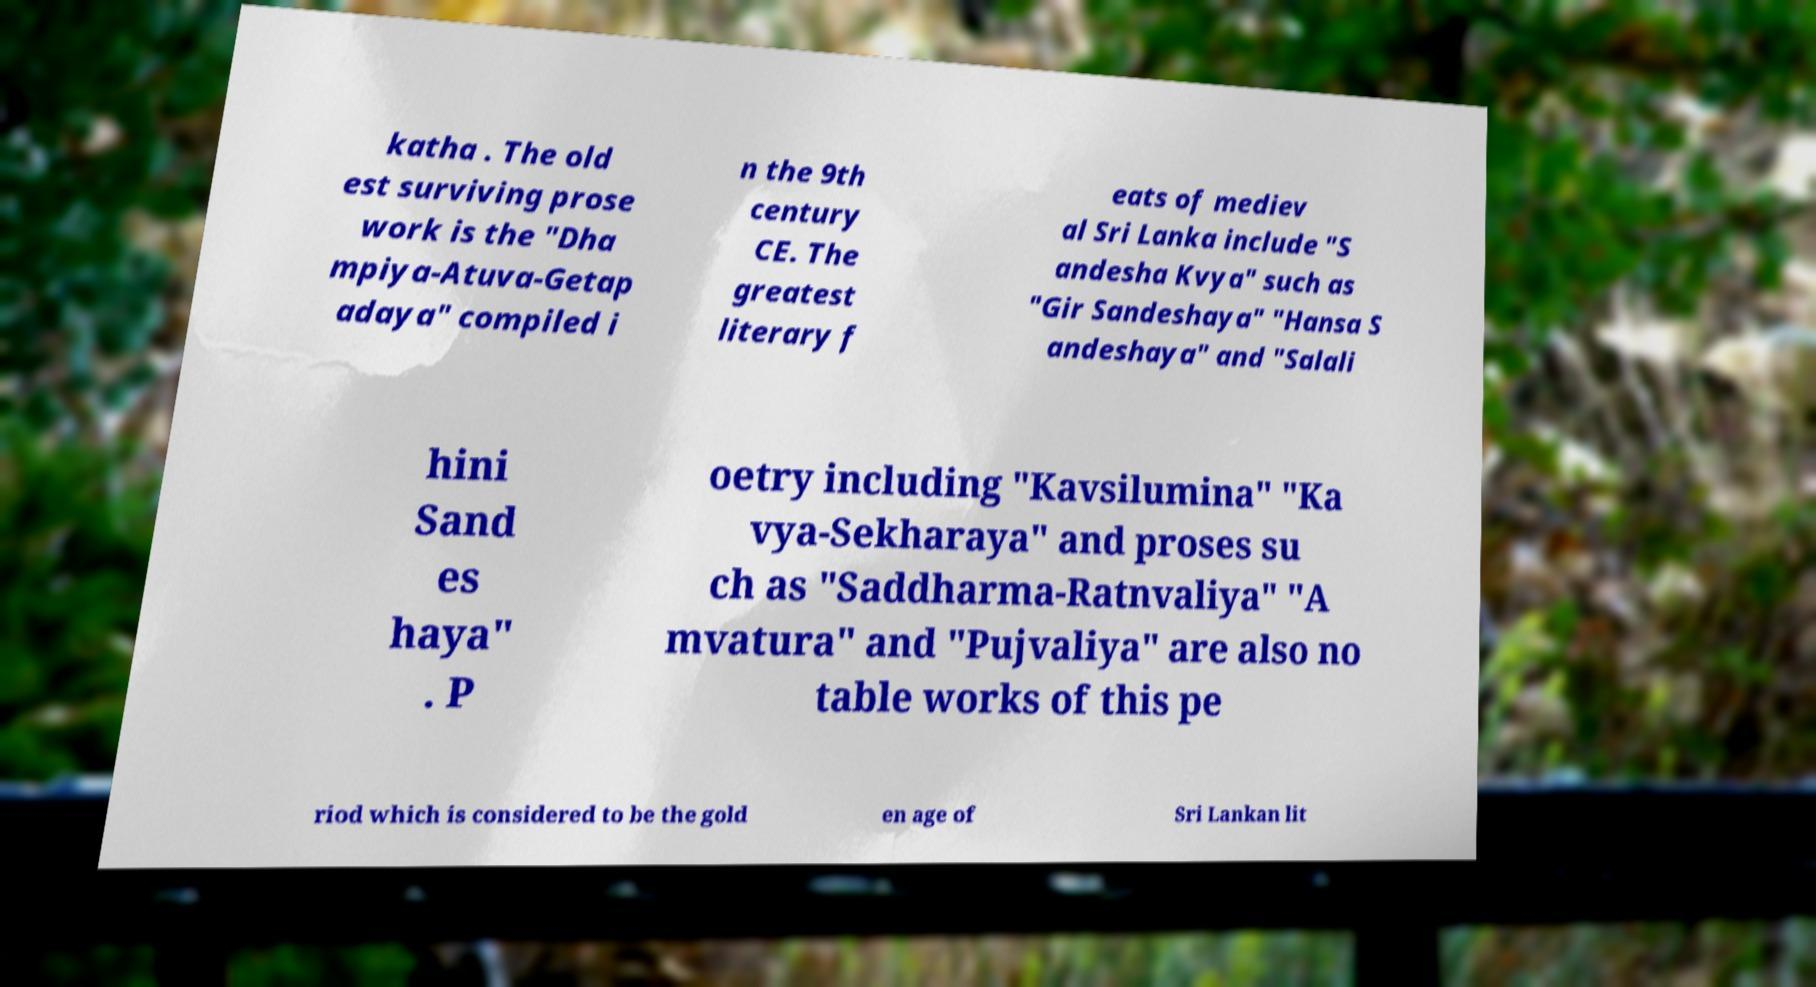For documentation purposes, I need the text within this image transcribed. Could you provide that? katha . The old est surviving prose work is the "Dha mpiya-Atuva-Getap adaya" compiled i n the 9th century CE. The greatest literary f eats of mediev al Sri Lanka include "S andesha Kvya" such as "Gir Sandeshaya" "Hansa S andeshaya" and "Salali hini Sand es haya" . P oetry including "Kavsilumina" "Ka vya-Sekharaya" and proses su ch as "Saddharma-Ratnvaliya" "A mvatura" and "Pujvaliya" are also no table works of this pe riod which is considered to be the gold en age of Sri Lankan lit 